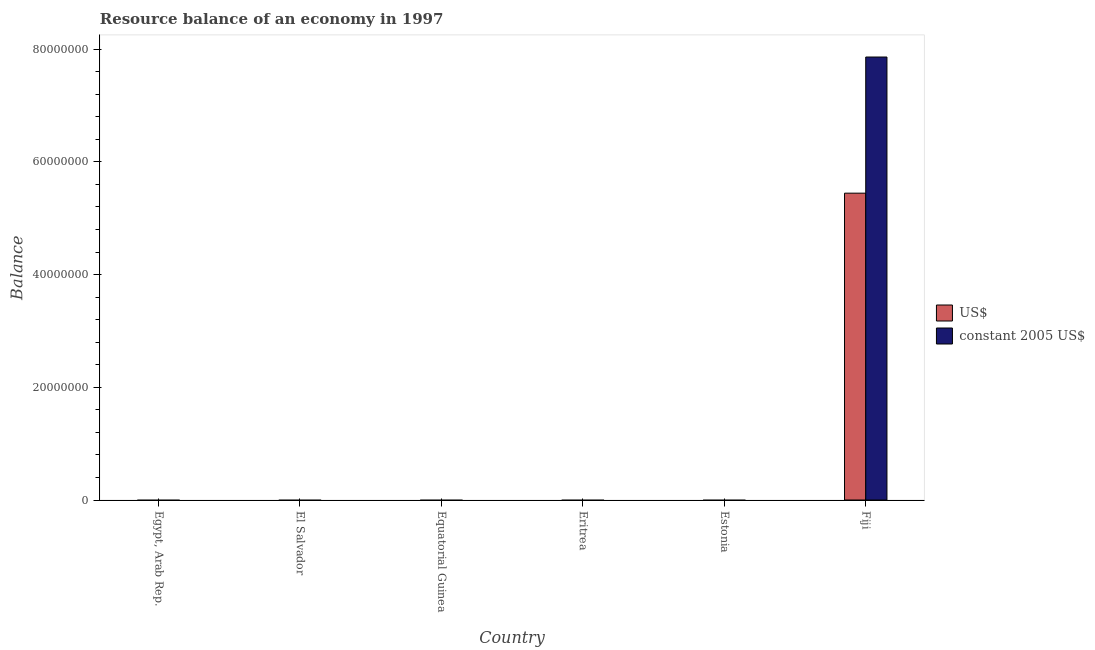How many different coloured bars are there?
Make the answer very short. 2. Are the number of bars per tick equal to the number of legend labels?
Keep it short and to the point. No. Are the number of bars on each tick of the X-axis equal?
Offer a terse response. No. How many bars are there on the 5th tick from the right?
Your response must be concise. 0. What is the label of the 3rd group of bars from the left?
Your response must be concise. Equatorial Guinea. In how many cases, is the number of bars for a given country not equal to the number of legend labels?
Your answer should be very brief. 5. Across all countries, what is the maximum resource balance in us$?
Provide a short and direct response. 5.44e+07. In which country was the resource balance in us$ maximum?
Provide a short and direct response. Fiji. What is the total resource balance in us$ in the graph?
Make the answer very short. 5.44e+07. What is the difference between the resource balance in constant us$ in Fiji and the resource balance in us$ in Egypt, Arab Rep.?
Ensure brevity in your answer.  7.86e+07. What is the average resource balance in constant us$ per country?
Your response must be concise. 1.31e+07. What is the difference between the resource balance in us$ and resource balance in constant us$ in Fiji?
Offer a terse response. -2.42e+07. In how many countries, is the resource balance in constant us$ greater than 28000000 units?
Your response must be concise. 1. What is the difference between the highest and the lowest resource balance in us$?
Provide a short and direct response. 5.44e+07. In how many countries, is the resource balance in constant us$ greater than the average resource balance in constant us$ taken over all countries?
Your answer should be compact. 1. How many bars are there?
Your answer should be very brief. 2. Are all the bars in the graph horizontal?
Your answer should be very brief. No. How many countries are there in the graph?
Offer a very short reply. 6. What is the difference between two consecutive major ticks on the Y-axis?
Give a very brief answer. 2.00e+07. Are the values on the major ticks of Y-axis written in scientific E-notation?
Make the answer very short. No. How many legend labels are there?
Give a very brief answer. 2. How are the legend labels stacked?
Make the answer very short. Vertical. What is the title of the graph?
Ensure brevity in your answer.  Resource balance of an economy in 1997. Does "Foreign liabilities" appear as one of the legend labels in the graph?
Offer a terse response. No. What is the label or title of the Y-axis?
Your answer should be compact. Balance. What is the Balance of US$ in Egypt, Arab Rep.?
Your answer should be compact. 0. What is the Balance of US$ in El Salvador?
Your answer should be compact. 0. What is the Balance in constant 2005 US$ in El Salvador?
Offer a very short reply. 0. What is the Balance in US$ in Equatorial Guinea?
Your answer should be very brief. 0. What is the Balance of US$ in Eritrea?
Ensure brevity in your answer.  0. What is the Balance in constant 2005 US$ in Estonia?
Your response must be concise. 0. What is the Balance in US$ in Fiji?
Offer a very short reply. 5.44e+07. What is the Balance of constant 2005 US$ in Fiji?
Make the answer very short. 7.86e+07. Across all countries, what is the maximum Balance in US$?
Give a very brief answer. 5.44e+07. Across all countries, what is the maximum Balance of constant 2005 US$?
Offer a very short reply. 7.86e+07. Across all countries, what is the minimum Balance of US$?
Your answer should be very brief. 0. What is the total Balance of US$ in the graph?
Give a very brief answer. 5.44e+07. What is the total Balance in constant 2005 US$ in the graph?
Offer a terse response. 7.86e+07. What is the average Balance of US$ per country?
Offer a terse response. 9.07e+06. What is the average Balance of constant 2005 US$ per country?
Your answer should be compact. 1.31e+07. What is the difference between the Balance in US$ and Balance in constant 2005 US$ in Fiji?
Offer a very short reply. -2.42e+07. What is the difference between the highest and the lowest Balance in US$?
Make the answer very short. 5.44e+07. What is the difference between the highest and the lowest Balance in constant 2005 US$?
Provide a short and direct response. 7.86e+07. 